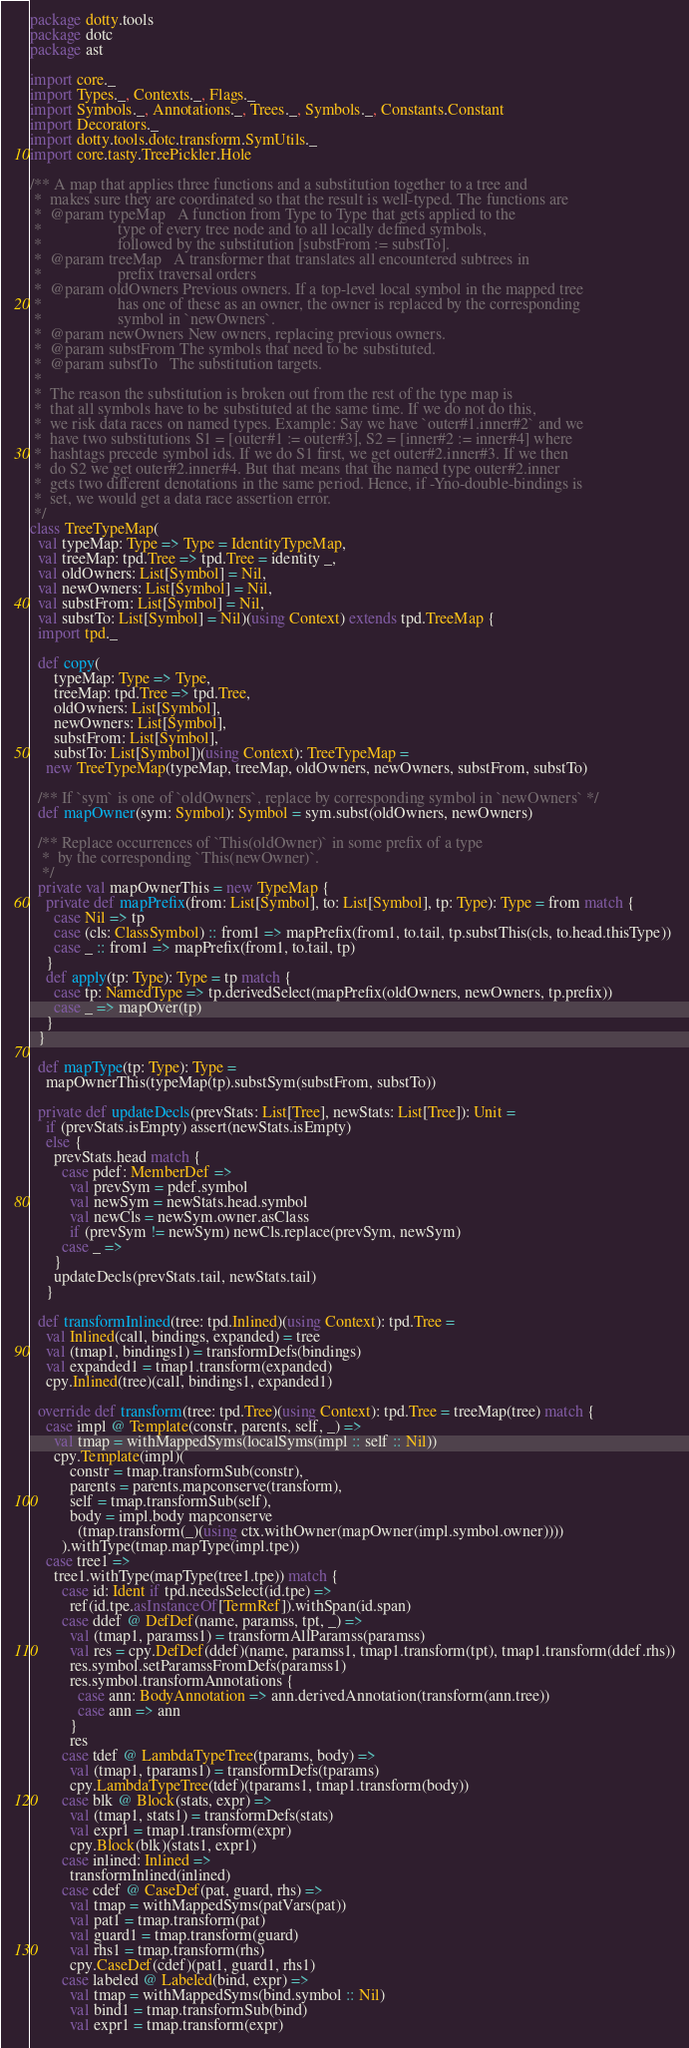Convert code to text. <code><loc_0><loc_0><loc_500><loc_500><_Scala_>package dotty.tools
package dotc
package ast

import core._
import Types._, Contexts._, Flags._
import Symbols._, Annotations._, Trees._, Symbols._, Constants.Constant
import Decorators._
import dotty.tools.dotc.transform.SymUtils._
import core.tasty.TreePickler.Hole

/** A map that applies three functions and a substitution together to a tree and
 *  makes sure they are coordinated so that the result is well-typed. The functions are
 *  @param typeMap   A function from Type to Type that gets applied to the
 *                   type of every tree node and to all locally defined symbols,
 *                   followed by the substitution [substFrom := substTo].
 *  @param treeMap   A transformer that translates all encountered subtrees in
 *                   prefix traversal orders
 *  @param oldOwners Previous owners. If a top-level local symbol in the mapped tree
 *                   has one of these as an owner, the owner is replaced by the corresponding
 *                   symbol in `newOwners`.
 *  @param newOwners New owners, replacing previous owners.
 *  @param substFrom The symbols that need to be substituted.
 *  @param substTo   The substitution targets.
 *
 *  The reason the substitution is broken out from the rest of the type map is
 *  that all symbols have to be substituted at the same time. If we do not do this,
 *  we risk data races on named types. Example: Say we have `outer#1.inner#2` and we
 *  have two substitutions S1 = [outer#1 := outer#3], S2 = [inner#2 := inner#4] where
 *  hashtags precede symbol ids. If we do S1 first, we get outer#2.inner#3. If we then
 *  do S2 we get outer#2.inner#4. But that means that the named type outer#2.inner
 *  gets two different denotations in the same period. Hence, if -Yno-double-bindings is
 *  set, we would get a data race assertion error.
 */
class TreeTypeMap(
  val typeMap: Type => Type = IdentityTypeMap,
  val treeMap: tpd.Tree => tpd.Tree = identity _,
  val oldOwners: List[Symbol] = Nil,
  val newOwners: List[Symbol] = Nil,
  val substFrom: List[Symbol] = Nil,
  val substTo: List[Symbol] = Nil)(using Context) extends tpd.TreeMap {
  import tpd._

  def copy(
      typeMap: Type => Type,
      treeMap: tpd.Tree => tpd.Tree,
      oldOwners: List[Symbol],
      newOwners: List[Symbol],
      substFrom: List[Symbol],
      substTo: List[Symbol])(using Context): TreeTypeMap =
    new TreeTypeMap(typeMap, treeMap, oldOwners, newOwners, substFrom, substTo)

  /** If `sym` is one of `oldOwners`, replace by corresponding symbol in `newOwners` */
  def mapOwner(sym: Symbol): Symbol = sym.subst(oldOwners, newOwners)

  /** Replace occurrences of `This(oldOwner)` in some prefix of a type
   *  by the corresponding `This(newOwner)`.
   */
  private val mapOwnerThis = new TypeMap {
    private def mapPrefix(from: List[Symbol], to: List[Symbol], tp: Type): Type = from match {
      case Nil => tp
      case (cls: ClassSymbol) :: from1 => mapPrefix(from1, to.tail, tp.substThis(cls, to.head.thisType))
      case _ :: from1 => mapPrefix(from1, to.tail, tp)
    }
    def apply(tp: Type): Type = tp match {
      case tp: NamedType => tp.derivedSelect(mapPrefix(oldOwners, newOwners, tp.prefix))
      case _ => mapOver(tp)
    }
  }

  def mapType(tp: Type): Type =
    mapOwnerThis(typeMap(tp).substSym(substFrom, substTo))

  private def updateDecls(prevStats: List[Tree], newStats: List[Tree]): Unit =
    if (prevStats.isEmpty) assert(newStats.isEmpty)
    else {
      prevStats.head match {
        case pdef: MemberDef =>
          val prevSym = pdef.symbol
          val newSym = newStats.head.symbol
          val newCls = newSym.owner.asClass
          if (prevSym != newSym) newCls.replace(prevSym, newSym)
        case _ =>
      }
      updateDecls(prevStats.tail, newStats.tail)
    }

  def transformInlined(tree: tpd.Inlined)(using Context): tpd.Tree =
    val Inlined(call, bindings, expanded) = tree
    val (tmap1, bindings1) = transformDefs(bindings)
    val expanded1 = tmap1.transform(expanded)
    cpy.Inlined(tree)(call, bindings1, expanded1)

  override def transform(tree: tpd.Tree)(using Context): tpd.Tree = treeMap(tree) match {
    case impl @ Template(constr, parents, self, _) =>
      val tmap = withMappedSyms(localSyms(impl :: self :: Nil))
      cpy.Template(impl)(
          constr = tmap.transformSub(constr),
          parents = parents.mapconserve(transform),
          self = tmap.transformSub(self),
          body = impl.body mapconserve
            (tmap.transform(_)(using ctx.withOwner(mapOwner(impl.symbol.owner))))
        ).withType(tmap.mapType(impl.tpe))
    case tree1 =>
      tree1.withType(mapType(tree1.tpe)) match {
        case id: Ident if tpd.needsSelect(id.tpe) =>
          ref(id.tpe.asInstanceOf[TermRef]).withSpan(id.span)
        case ddef @ DefDef(name, paramss, tpt, _) =>
          val (tmap1, paramss1) = transformAllParamss(paramss)
          val res = cpy.DefDef(ddef)(name, paramss1, tmap1.transform(tpt), tmap1.transform(ddef.rhs))
          res.symbol.setParamssFromDefs(paramss1)
          res.symbol.transformAnnotations {
            case ann: BodyAnnotation => ann.derivedAnnotation(transform(ann.tree))
            case ann => ann
          }
          res
        case tdef @ LambdaTypeTree(tparams, body) =>
          val (tmap1, tparams1) = transformDefs(tparams)
          cpy.LambdaTypeTree(tdef)(tparams1, tmap1.transform(body))
        case blk @ Block(stats, expr) =>
          val (tmap1, stats1) = transformDefs(stats)
          val expr1 = tmap1.transform(expr)
          cpy.Block(blk)(stats1, expr1)
        case inlined: Inlined =>
          transformInlined(inlined)
        case cdef @ CaseDef(pat, guard, rhs) =>
          val tmap = withMappedSyms(patVars(pat))
          val pat1 = tmap.transform(pat)
          val guard1 = tmap.transform(guard)
          val rhs1 = tmap.transform(rhs)
          cpy.CaseDef(cdef)(pat1, guard1, rhs1)
        case labeled @ Labeled(bind, expr) =>
          val tmap = withMappedSyms(bind.symbol :: Nil)
          val bind1 = tmap.transformSub(bind)
          val expr1 = tmap.transform(expr)</code> 